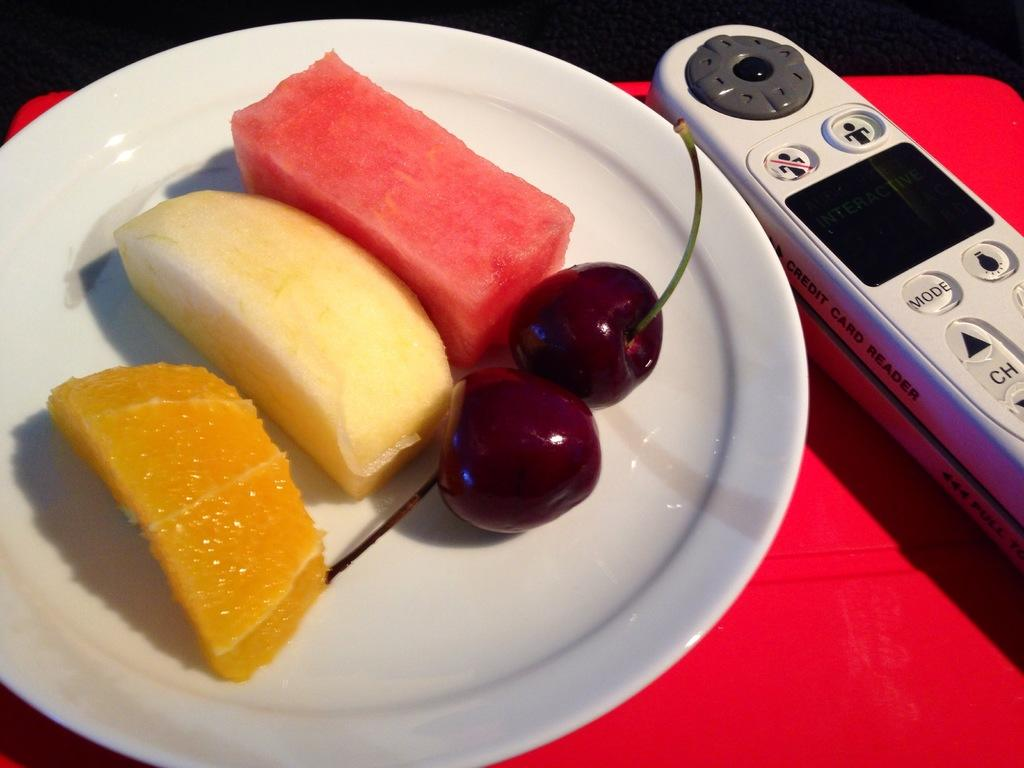Provide a one-sentence caption for the provided image. remote with mode button beside plate of fruit. 